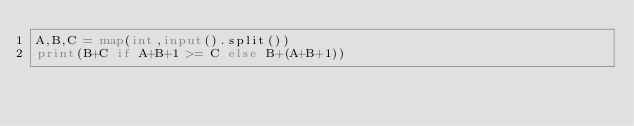<code> <loc_0><loc_0><loc_500><loc_500><_Python_>A,B,C = map(int,input().split())
print(B+C if A+B+1 >= C else B+(A+B+1))</code> 